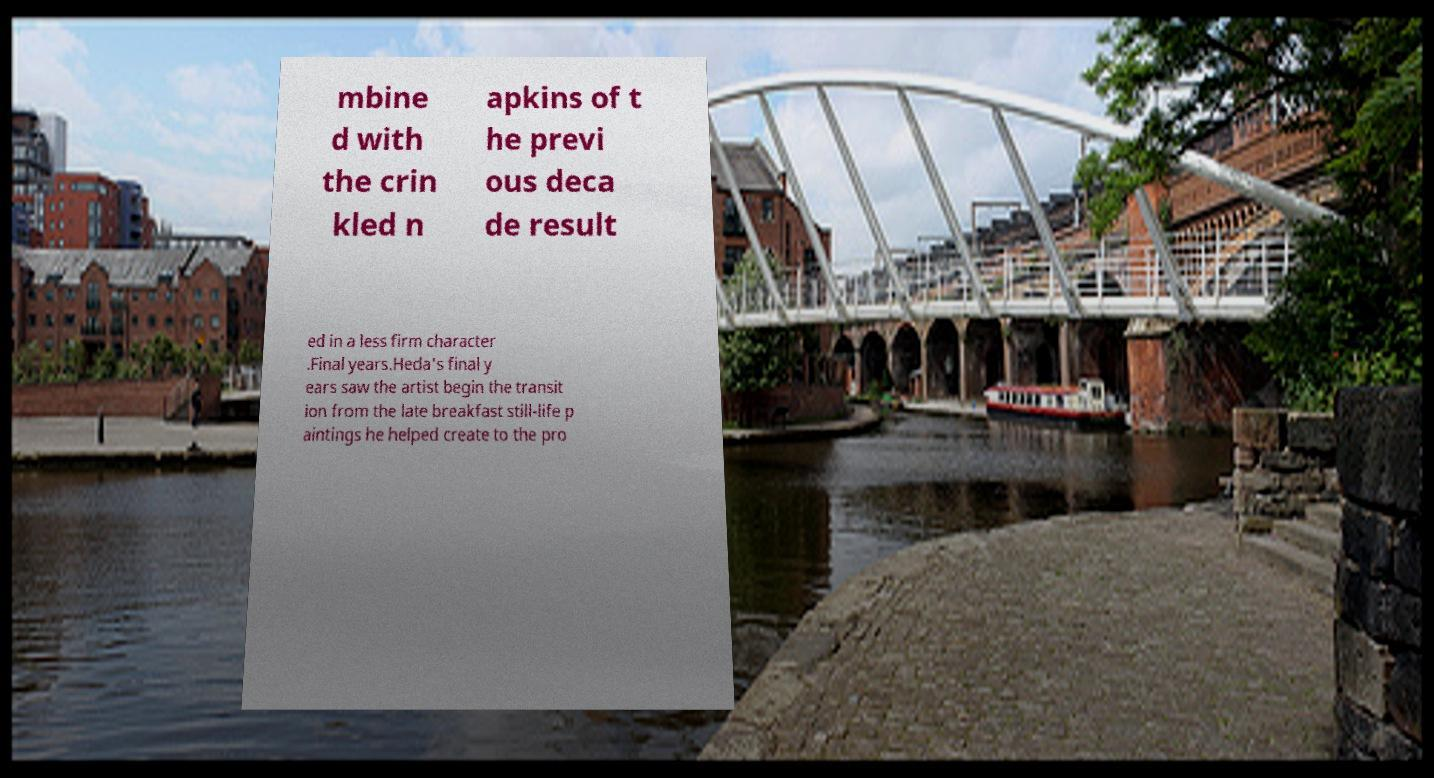There's text embedded in this image that I need extracted. Can you transcribe it verbatim? mbine d with the crin kled n apkins of t he previ ous deca de result ed in a less firm character .Final years.Heda's final y ears saw the artist begin the transit ion from the late breakfast still-life p aintings he helped create to the pro 